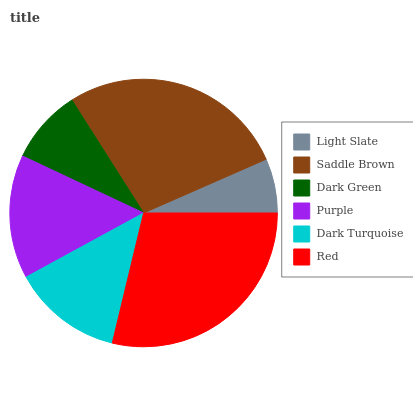Is Light Slate the minimum?
Answer yes or no. Yes. Is Red the maximum?
Answer yes or no. Yes. Is Saddle Brown the minimum?
Answer yes or no. No. Is Saddle Brown the maximum?
Answer yes or no. No. Is Saddle Brown greater than Light Slate?
Answer yes or no. Yes. Is Light Slate less than Saddle Brown?
Answer yes or no. Yes. Is Light Slate greater than Saddle Brown?
Answer yes or no. No. Is Saddle Brown less than Light Slate?
Answer yes or no. No. Is Purple the high median?
Answer yes or no. Yes. Is Dark Turquoise the low median?
Answer yes or no. Yes. Is Red the high median?
Answer yes or no. No. Is Red the low median?
Answer yes or no. No. 